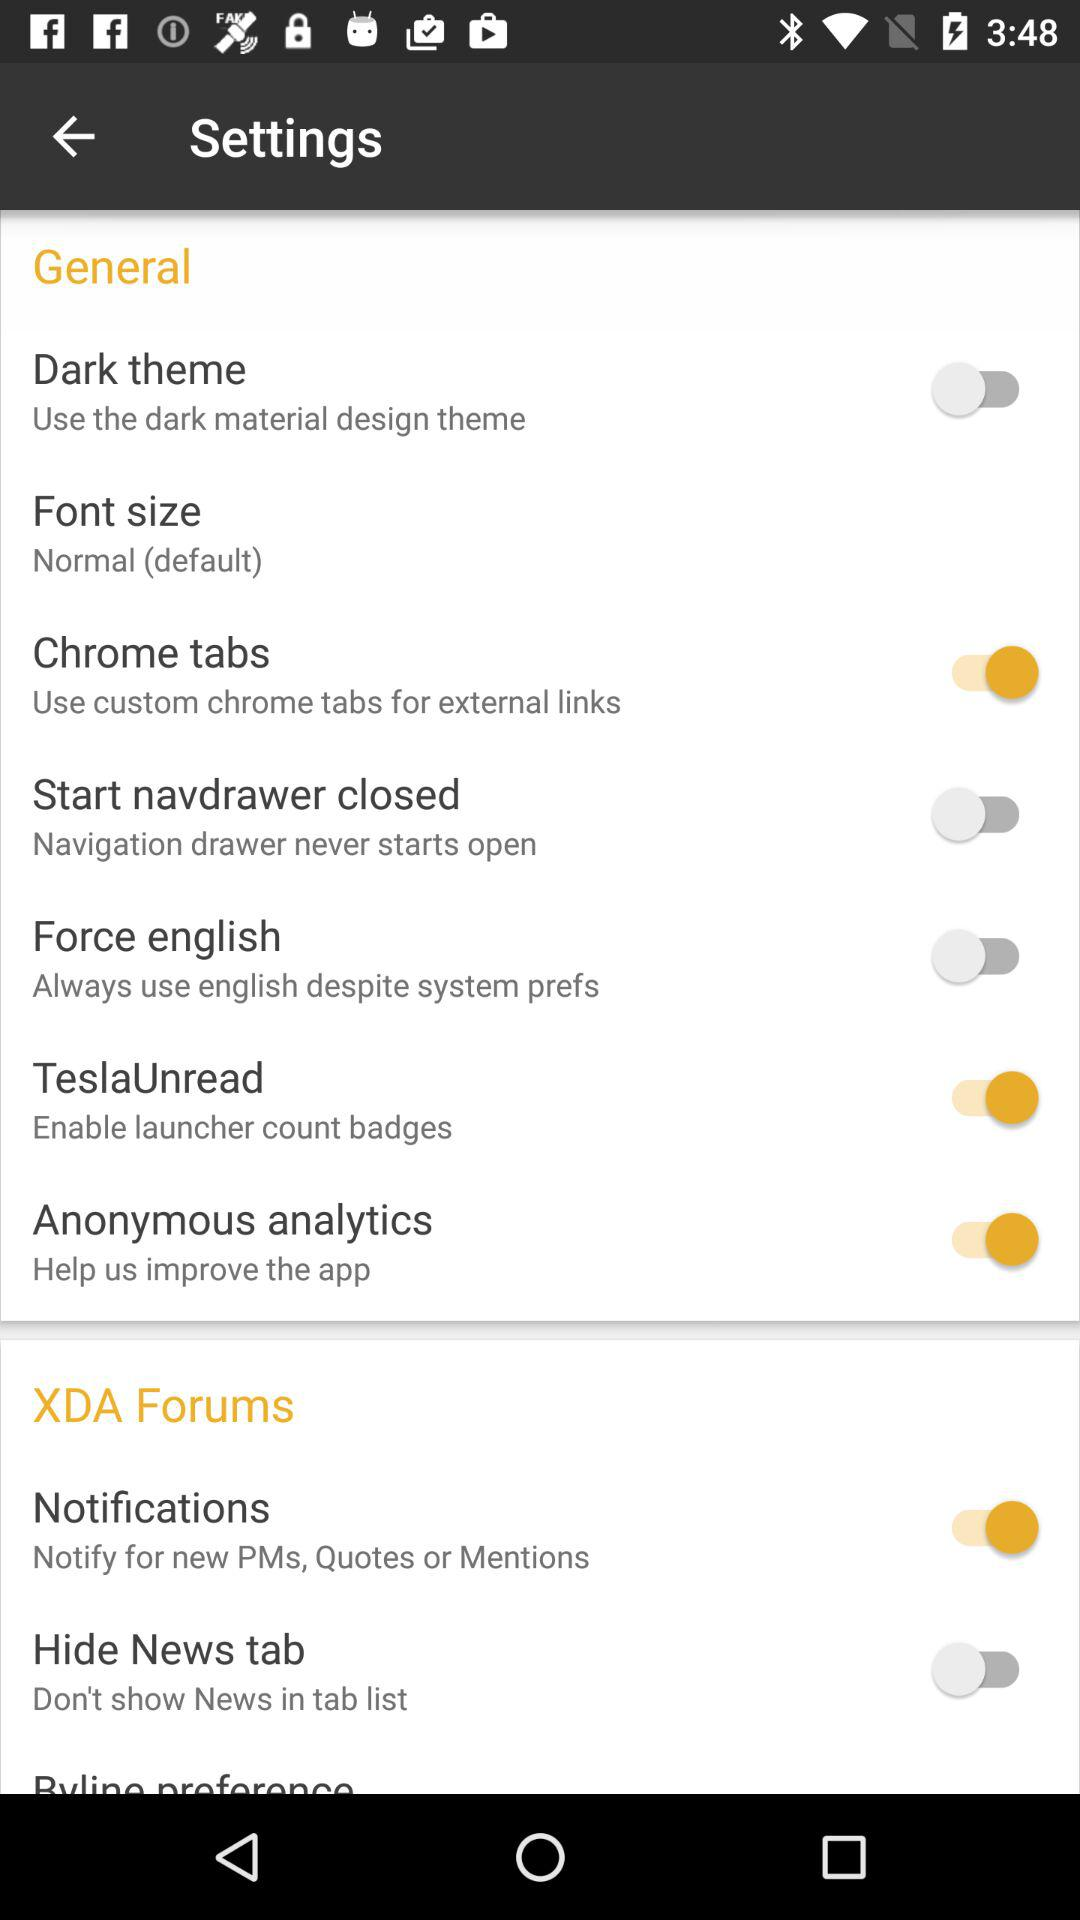What tabs can be used for external links? External links can be used in custom chrome tabs. 